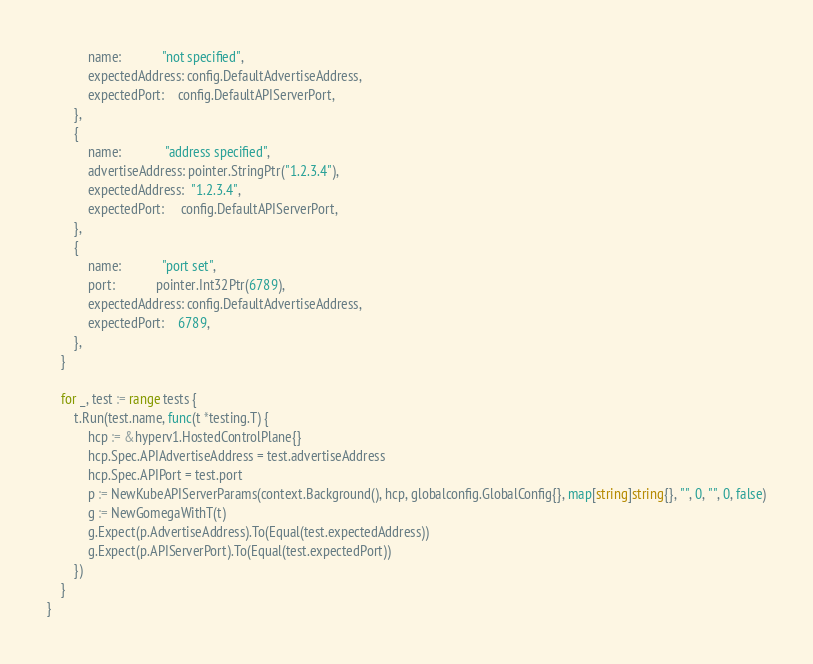<code> <loc_0><loc_0><loc_500><loc_500><_Go_>			name:            "not specified",
			expectedAddress: config.DefaultAdvertiseAddress,
			expectedPort:    config.DefaultAPIServerPort,
		},
		{
			name:             "address specified",
			advertiseAddress: pointer.StringPtr("1.2.3.4"),
			expectedAddress:  "1.2.3.4",
			expectedPort:     config.DefaultAPIServerPort,
		},
		{
			name:            "port set",
			port:            pointer.Int32Ptr(6789),
			expectedAddress: config.DefaultAdvertiseAddress,
			expectedPort:    6789,
		},
	}

	for _, test := range tests {
		t.Run(test.name, func(t *testing.T) {
			hcp := &hyperv1.HostedControlPlane{}
			hcp.Spec.APIAdvertiseAddress = test.advertiseAddress
			hcp.Spec.APIPort = test.port
			p := NewKubeAPIServerParams(context.Background(), hcp, globalconfig.GlobalConfig{}, map[string]string{}, "", 0, "", 0, false)
			g := NewGomegaWithT(t)
			g.Expect(p.AdvertiseAddress).To(Equal(test.expectedAddress))
			g.Expect(p.APIServerPort).To(Equal(test.expectedPort))
		})
	}
}
</code> 